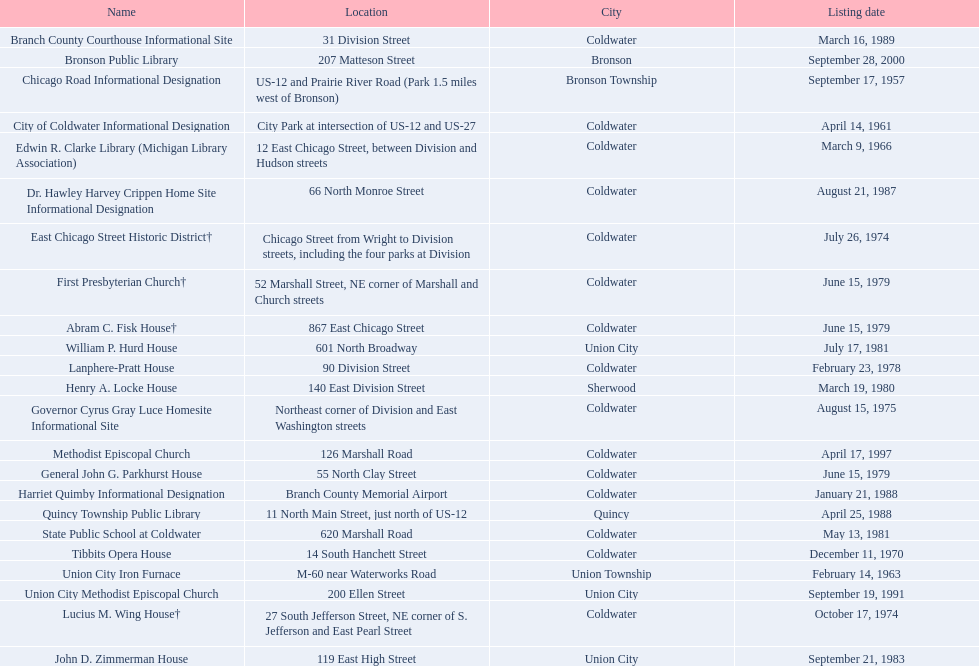Are there any sites that were listed before 1960? September 17, 1957. If yes, can you provide the name of the site that was listed pre-1960? Chicago Road Informational Designation. 